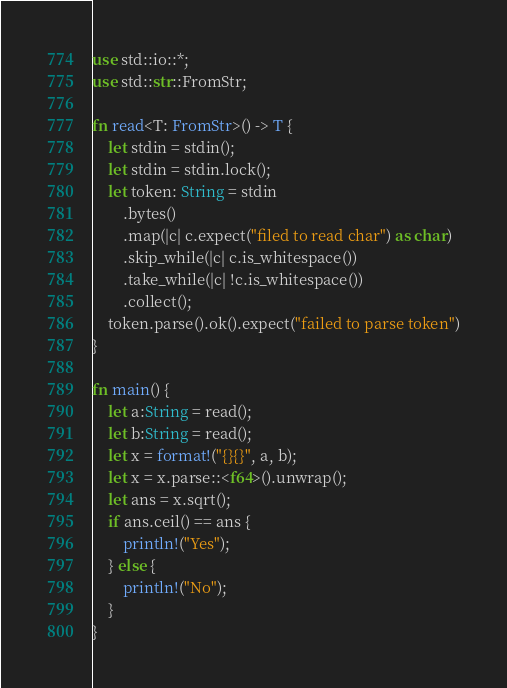Convert code to text. <code><loc_0><loc_0><loc_500><loc_500><_Rust_>use std::io::*;
use std::str::FromStr;

fn read<T: FromStr>() -> T {
    let stdin = stdin();
    let stdin = stdin.lock();
    let token: String = stdin
        .bytes()
        .map(|c| c.expect("filed to read char") as char)
        .skip_while(|c| c.is_whitespace())
        .take_while(|c| !c.is_whitespace())
        .collect();
    token.parse().ok().expect("failed to parse token")
}

fn main() {
    let a:String = read();
    let b:String = read();
    let x = format!("{}{}", a, b);
    let x = x.parse::<f64>().unwrap();
    let ans = x.sqrt();
    if ans.ceil() == ans {
        println!("Yes");
    } else {
        println!("No");
    }
}
</code> 